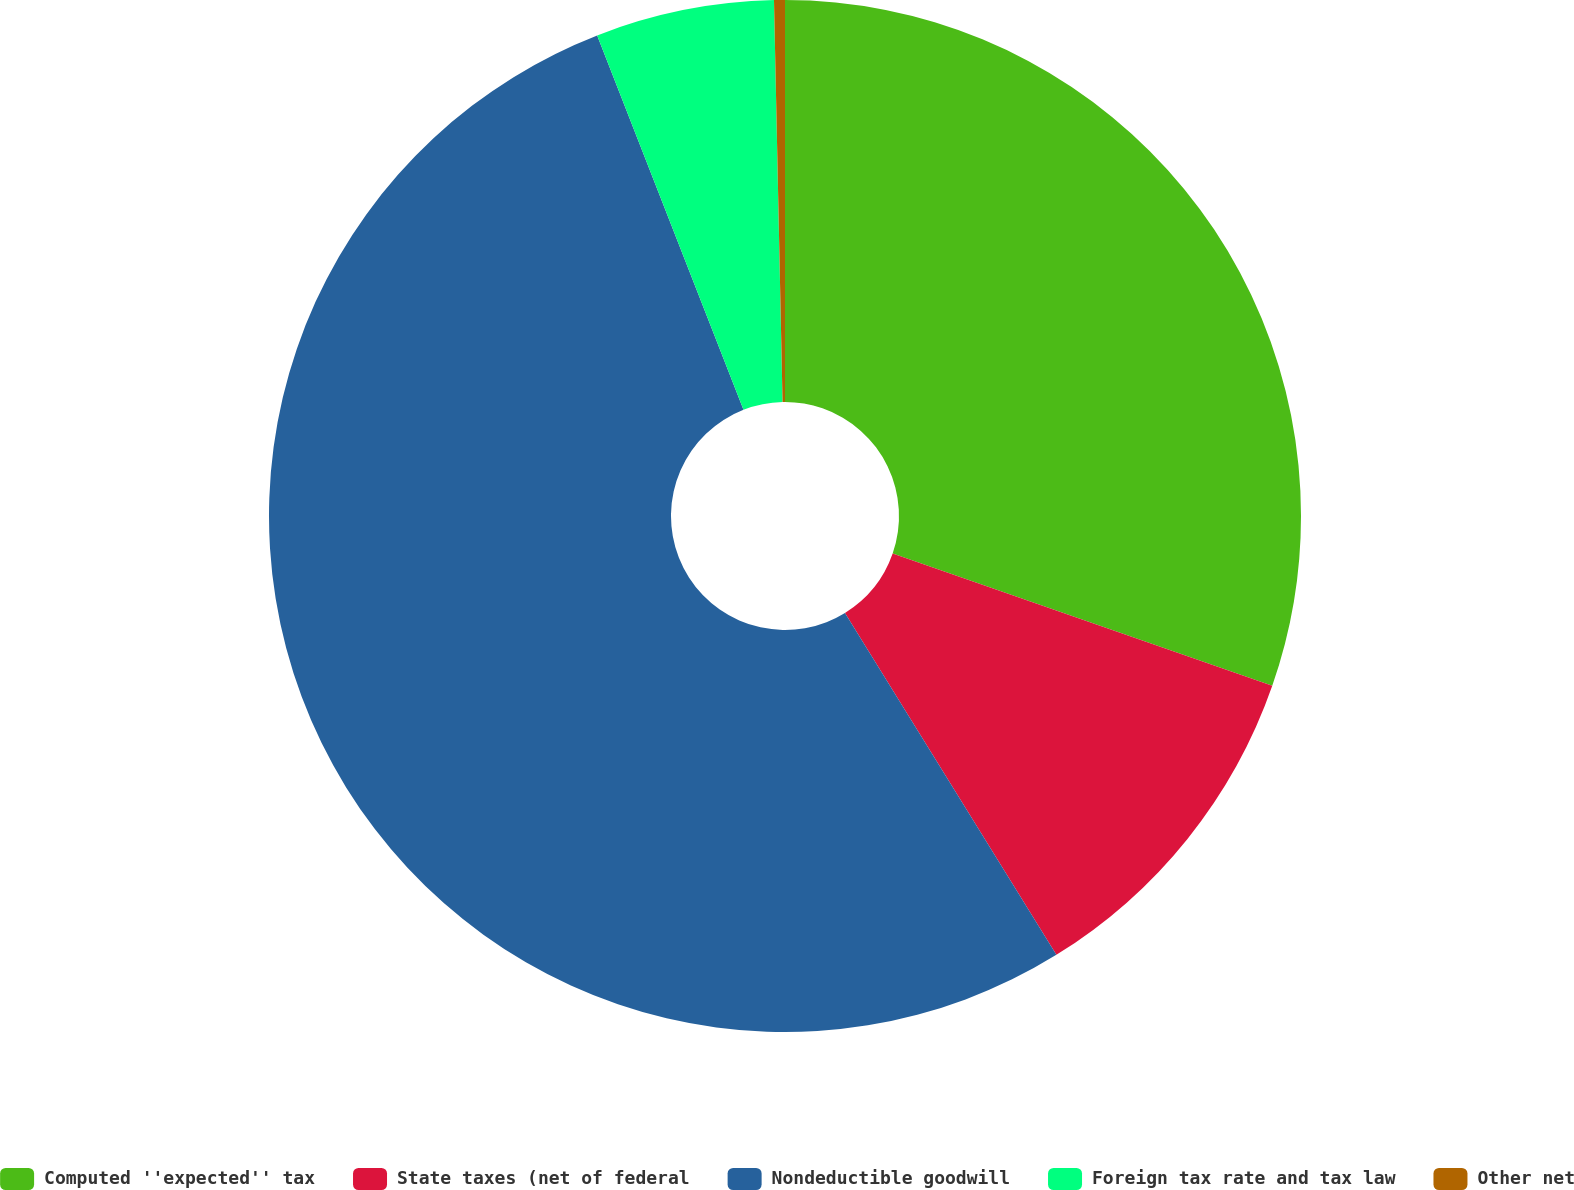<chart> <loc_0><loc_0><loc_500><loc_500><pie_chart><fcel>Computed ''expected'' tax<fcel>State taxes (net of federal<fcel>Nondeductible goodwill<fcel>Foreign tax rate and tax law<fcel>Other net<nl><fcel>30.34%<fcel>10.85%<fcel>52.89%<fcel>5.59%<fcel>0.34%<nl></chart> 